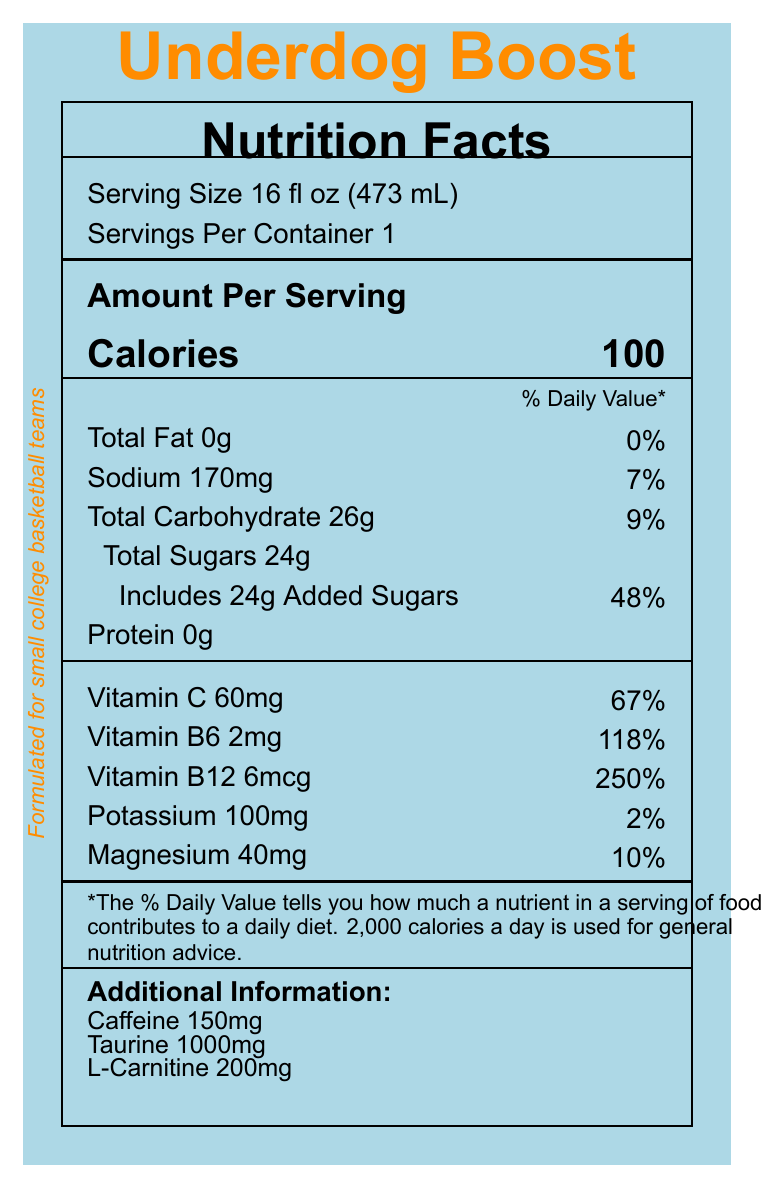what is the serving size of Underdog Boost? The serving size is mentioned on the top left of the Nutrition Facts label as "Serving Size 16 fl oz (473 mL)."
Answer: 16 fl oz (473 mL) how many servings per container? The label states "Servings Per Container 1," indicating there is one serving per container.
Answer: 1 how many calories are in one serving of Underdog Boost? The number of calories is listed next to "Calories" and is indicated as 100.
Answer: 100 what is the total fat content in Underdog Boost? The total fat content is specified as "Total Fat 0g."
Answer: 0g what percentage of the daily value does the sodium content of Underdog Boost represent? The sodium content is listed as 170mg, which is 7% of the daily value.
Answer: 7% how much protein is in a serving of Underdog Boost? The label lists "Protein 0g," indicating that there is no protein in the drink.
Answer: 0g how much added sugar does a serving of Underdog Boost contain? The document specifies "Includes 24g Added Sugars."
Answer: 24g what vitamin has the highest daily value percentage in Underdog Boost? Vitamin B12 is listed with 6mcg and a daily value of 250%, which is the highest among all listed vitamins and minerals.
Answer: Vitamin B12 with 250% what are the three main ingredients in Underdog Boost? A. Caffeine, Taurine, L-Carnitine B. Filtered water, Fructose, Citric acid C. Dextrose, Fructose, Taurine The ingredients list starts with "Filtered water," followed by "Dextrose" and "Fructose," making B the correct option.
Answer: B: Filtered water, Fructose, Citric acid which nutrient contributes the most to the percentage of daily value in one serving? A. Protein B. Vitamin B6 C. Vitamin B12 D. Magnesium Vitamin B12 has the highest daily value percentage at 250%.
Answer: C: Vitamin B12 does Underdog Boost contain any artificial colors or preservatives? The label's marketing claims include "No artificial colors or preservatives."
Answer: No is there any allergen information provided on the label? The allergen information states that it is "Manufactured in a facility that processes milk and soy products."
Answer: Yes summarize the main claims and nutritional highlights of Underdog Boost. The summary covers the drink's nutritional content, key ingredients, vitamins, and minerals, as well as the marketing claims and special dedication to small college teams.
Answer: Underdog Boost is a sports energy drink designed for small college basketball teams. It contains 100 calories per serving, has 0g of fat and 0g of protein, and provides a significant amount of added sugars (24g). Key vitamins and minerals include Vitamin C (67% DV), Vitamin B6 (118% DV), Vitamin B12(250% DV), Sodium (7% DV), Potassium (2% DV), and Magnesium (10% DV). The drink also includes 150mg of caffeine, 1000mg of Taurine, and 200mg of L-Carnitine. The label highlights that it supports endurance and focus, replenishes electrolytes, and contains no artificial colors or preservatives. The product is dedicated to small college teams striving for greatness. how many milligrams of taurine does Underdog Boost have? The Additional Information section lists "Taurine 1000mg."
Answer: 1000mg what is the main purpose of Underdog Boost according to the marketing claims? The marketing claims include "Formulated for small college basketball teams," "Supports endurance and focus during intense gameplay," and "Replenishes electrolytes lost through sweat."
Answer: To support endurance and focus during intense gameplay, and to replenish electrolytes lost through sweat. how much L-Carnitine is in each serving of Underdog Boost? The Additional Information section states "L-Carnitine 200mg."
Answer: 200mg what place is Underdog Boost manufactured in? The document does not provide details on the manufacturing location.
Answer: Not enough information who is Underdog Boost dedicated to? The small team dedication reads: "Dedicated to all the small college teams striving for greatness. Your hard work and determination inspire us every day."
Answer: Dedicated to all the small college teams striving for greatness. 